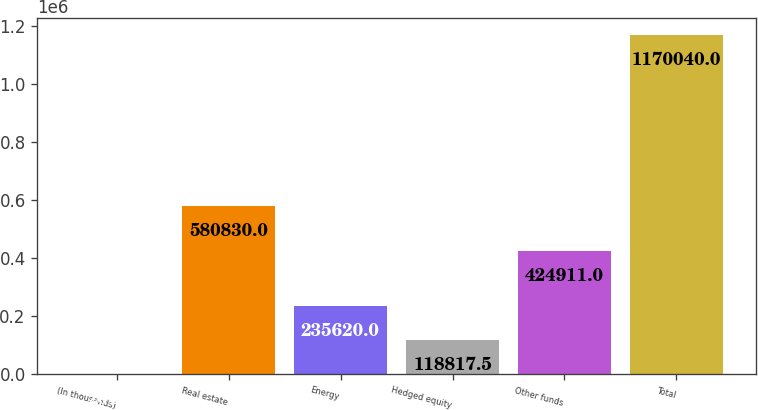Convert chart to OTSL. <chart><loc_0><loc_0><loc_500><loc_500><bar_chart><fcel>(In thousands)<fcel>Real estate<fcel>Energy<fcel>Hedged equity<fcel>Other funds<fcel>Total<nl><fcel>2015<fcel>580830<fcel>235620<fcel>118818<fcel>424911<fcel>1.17004e+06<nl></chart> 